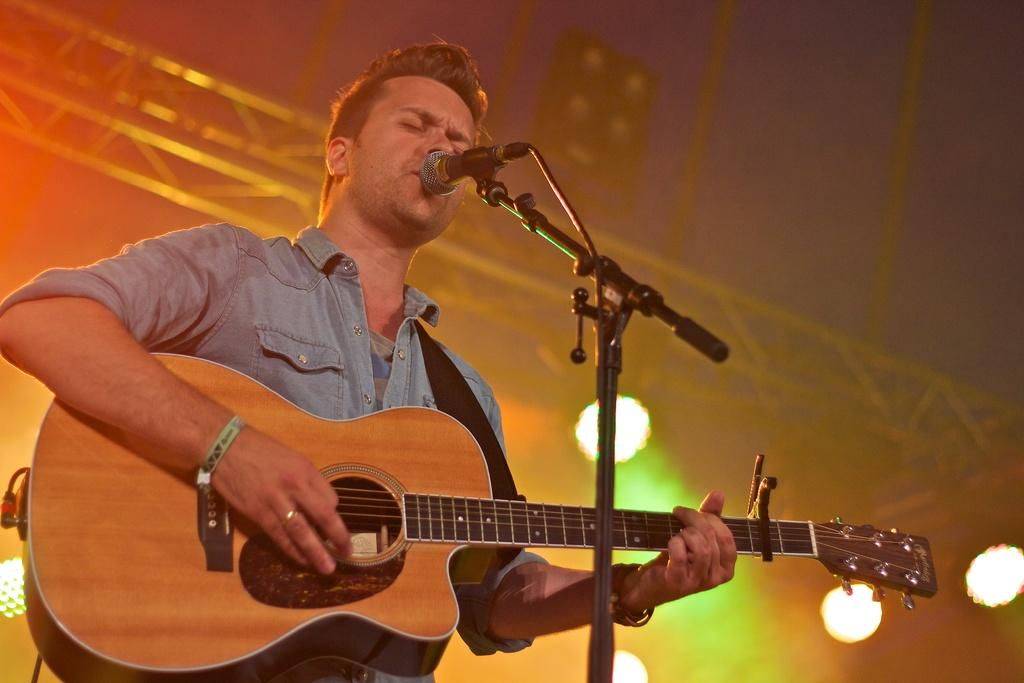What is the man in the image doing? The man is singing and playing a guitar. What object is the man holding while singing? The man is holding a microphone. Where is the man performing? The setting is a concert. What type of toothbrush is the man using to play the guitar in the image? There is no toothbrush present in the image, and the man is not using a toothbrush to play the guitar. 